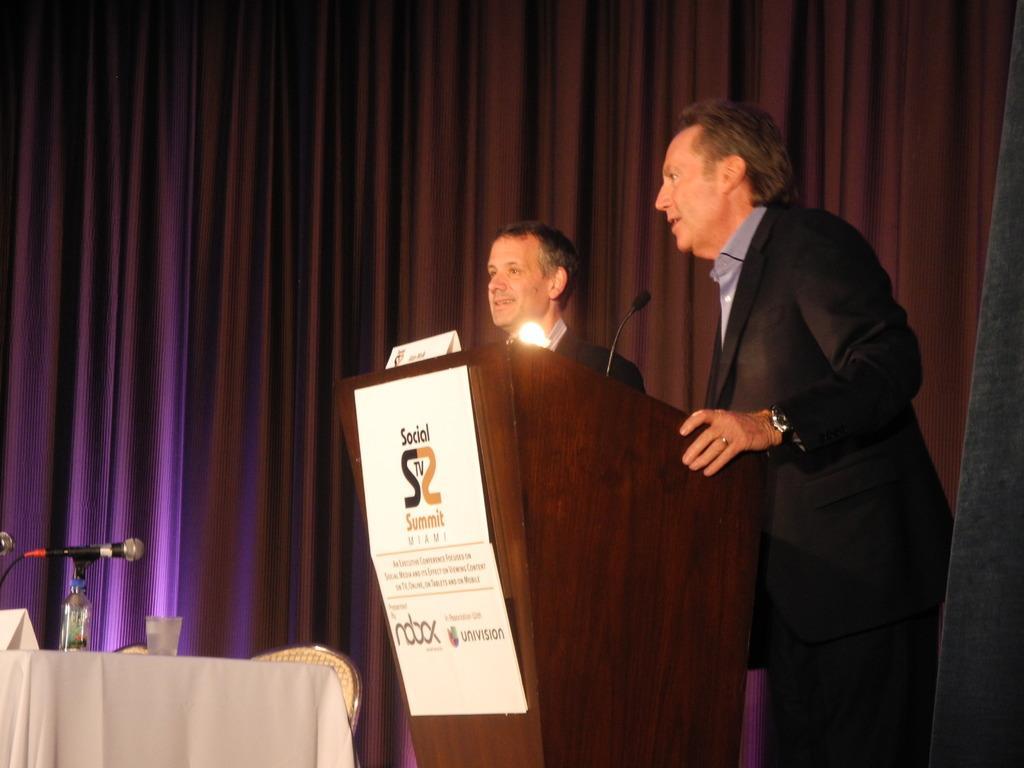How would you summarize this image in a sentence or two? In this picture I can see there are two people standing at the wooden table and they are speaking in the microphone and there is a table on to left, it has microphones and water bottles and glasses and there is a curtain in the backdrop. 